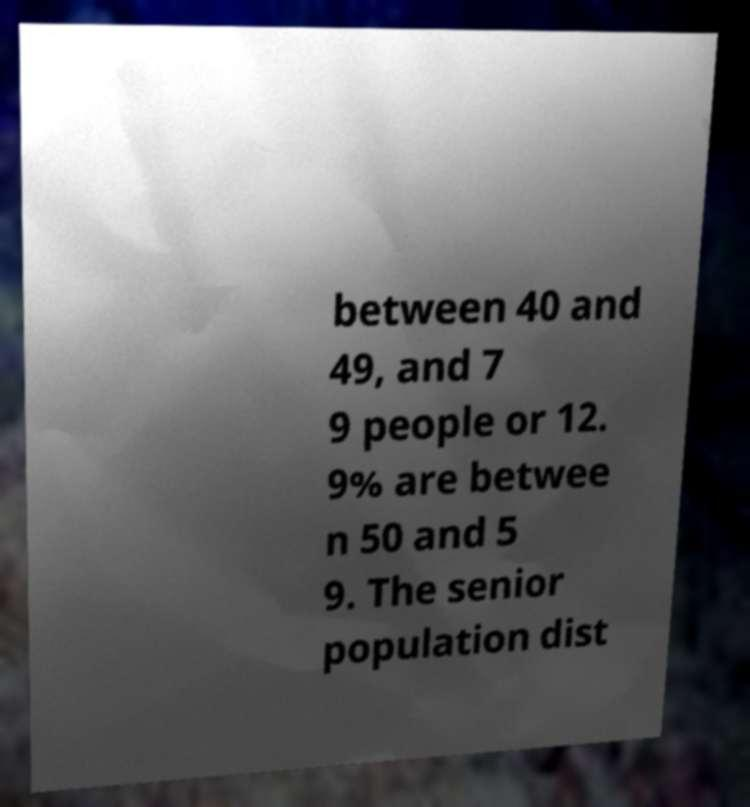For documentation purposes, I need the text within this image transcribed. Could you provide that? between 40 and 49, and 7 9 people or 12. 9% are betwee n 50 and 5 9. The senior population dist 